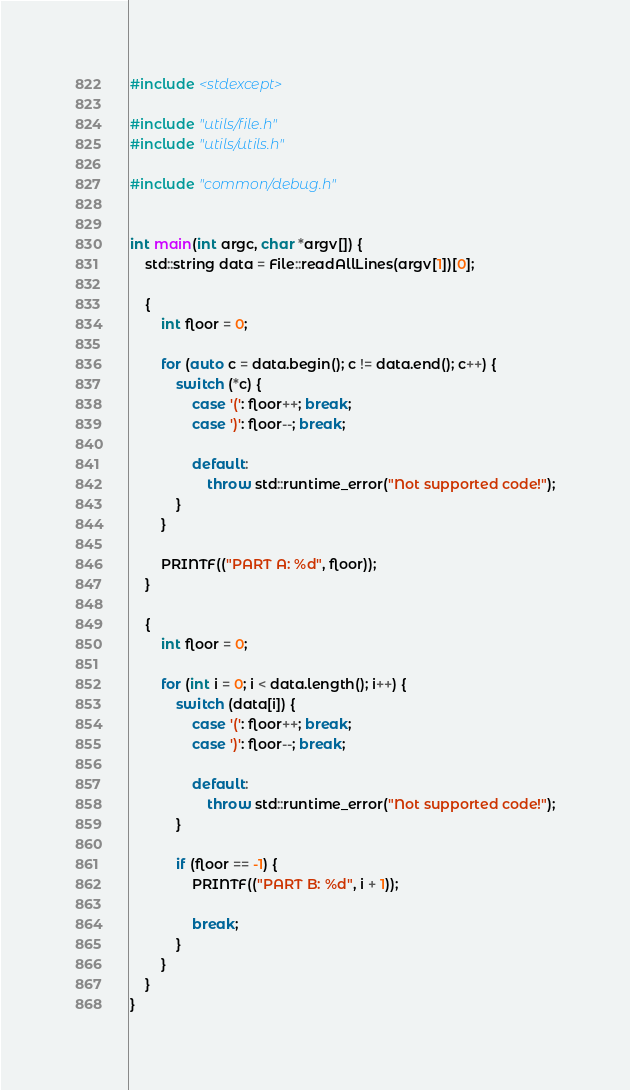Convert code to text. <code><loc_0><loc_0><loc_500><loc_500><_C++_>#include <stdexcept>

#include "utils/file.h"
#include "utils/utils.h"

#include "common/debug.h"


int main(int argc, char *argv[]) {
	std::string data = File::readAllLines(argv[1])[0];

	{
		int floor = 0;

		for (auto c = data.begin(); c != data.end(); c++) {
			switch (*c) {
				case '(': floor++; break;
				case ')': floor--; break;

				default:
					throw std::runtime_error("Not supported code!");
			}
		}

		PRINTF(("PART A: %d", floor));
	}

	{
		int floor = 0;

		for (int i = 0; i < data.length(); i++) {
			switch (data[i]) {
				case '(': floor++; break;
				case ')': floor--; break;

				default:
					throw std::runtime_error("Not supported code!");
			}

			if (floor == -1) {
				PRINTF(("PART B: %d", i + 1));

				break;
			}
		}
	}
}
</code> 